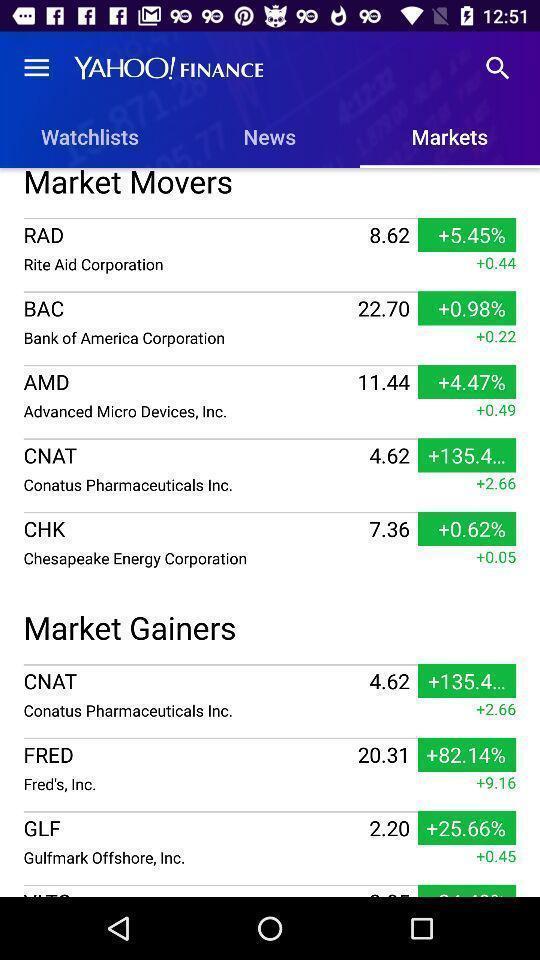Provide a textual representation of this image. Page showing list of different stocks in stock trading app. 